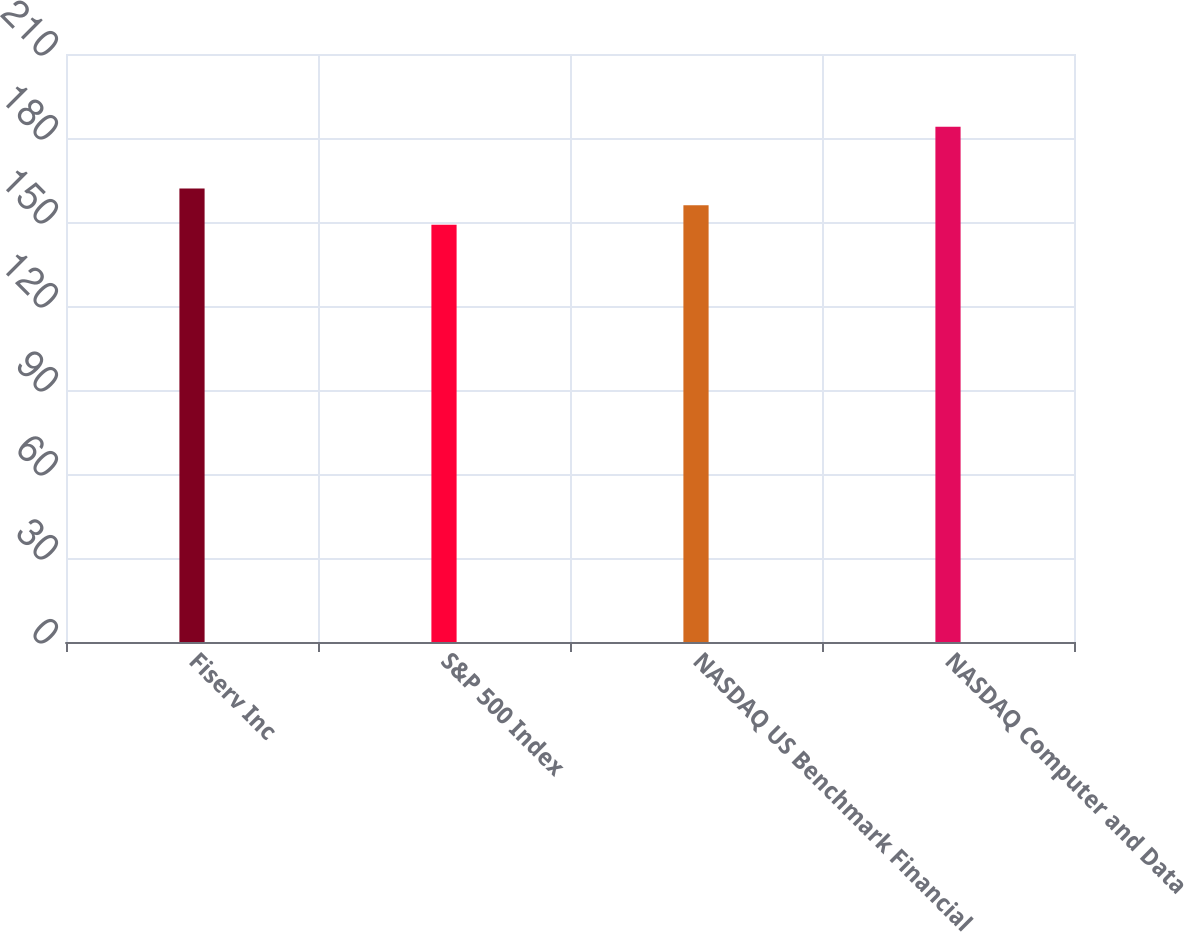Convert chart. <chart><loc_0><loc_0><loc_500><loc_500><bar_chart><fcel>Fiserv Inc<fcel>S&P 500 Index<fcel>NASDAQ US Benchmark Financial<fcel>NASDAQ Computer and Data<nl><fcel>162<fcel>149<fcel>156<fcel>184<nl></chart> 